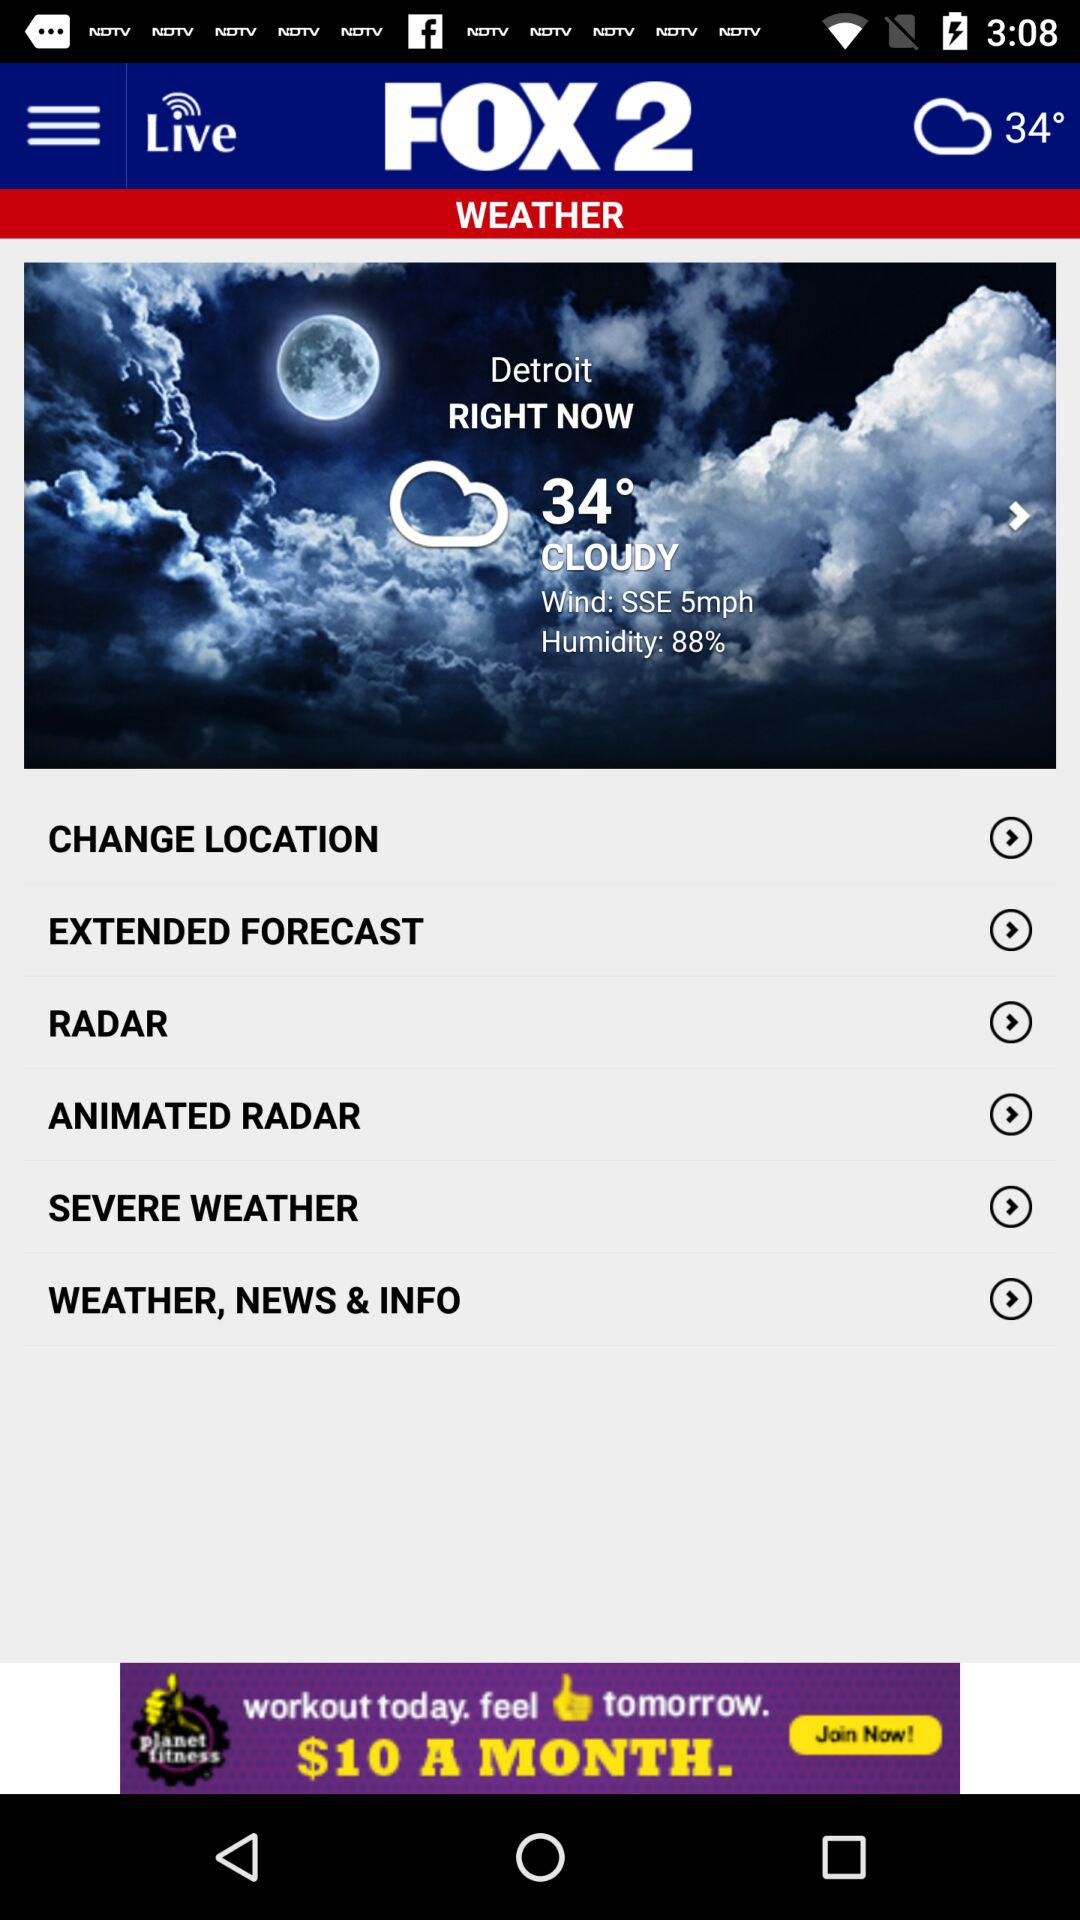How many degrees Fahrenheit is the temperature in Detroit?
Answer the question using a single word or phrase. 34° 